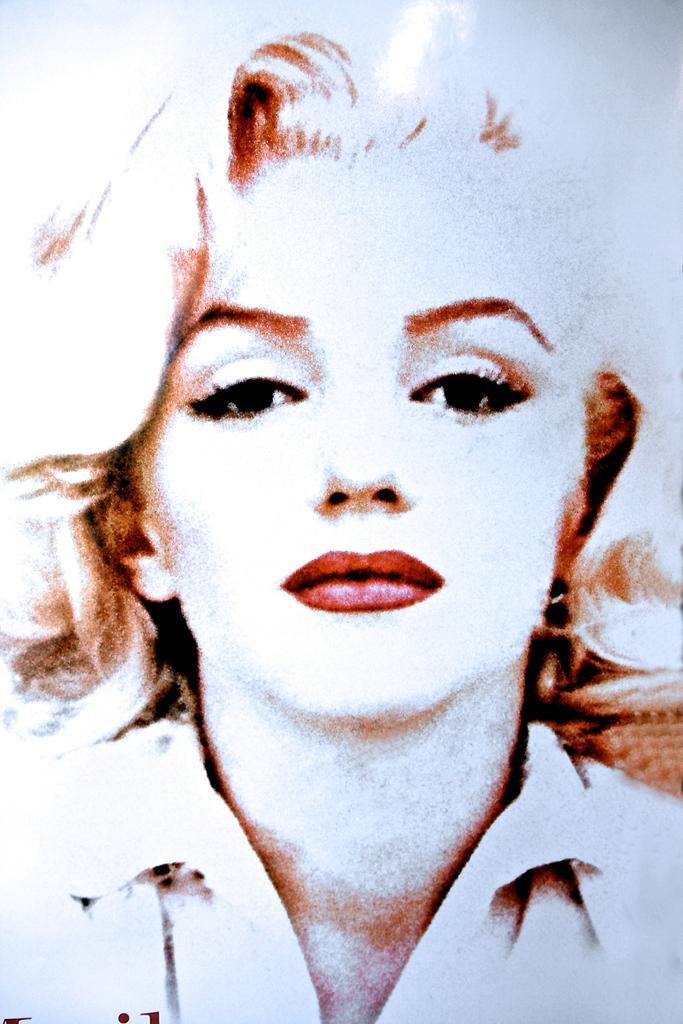In one or two sentences, can you explain what this image depicts? In this image we can see a lady person's face picture. 